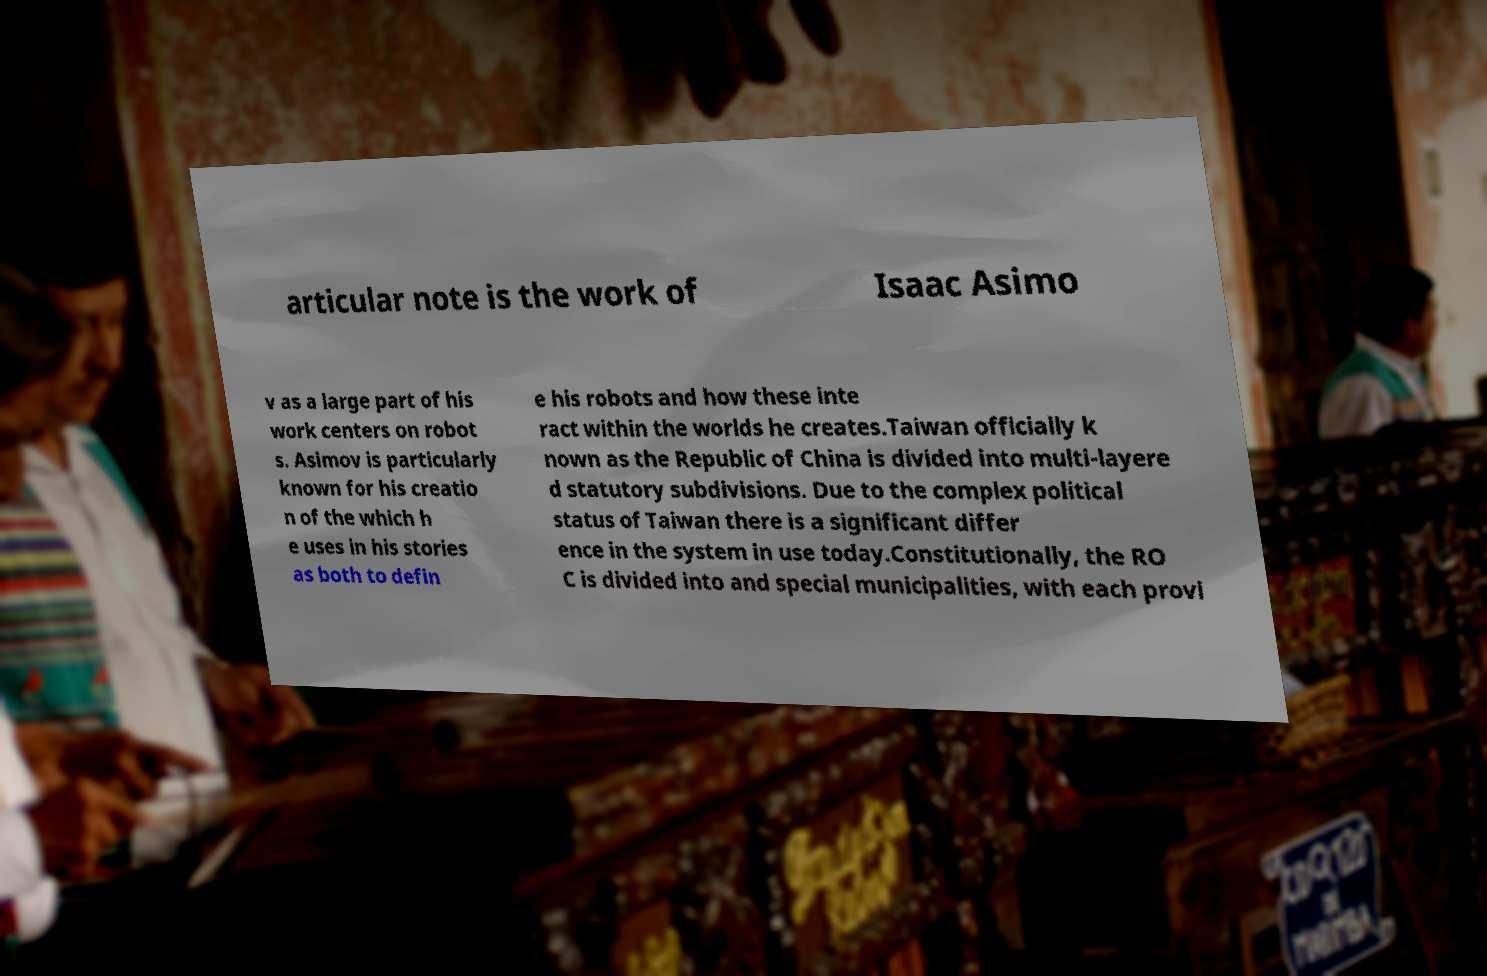For documentation purposes, I need the text within this image transcribed. Could you provide that? articular note is the work of Isaac Asimo v as a large part of his work centers on robot s. Asimov is particularly known for his creatio n of the which h e uses in his stories as both to defin e his robots and how these inte ract within the worlds he creates.Taiwan officially k nown as the Republic of China is divided into multi-layere d statutory subdivisions. Due to the complex political status of Taiwan there is a significant differ ence in the system in use today.Constitutionally, the RO C is divided into and special municipalities, with each provi 